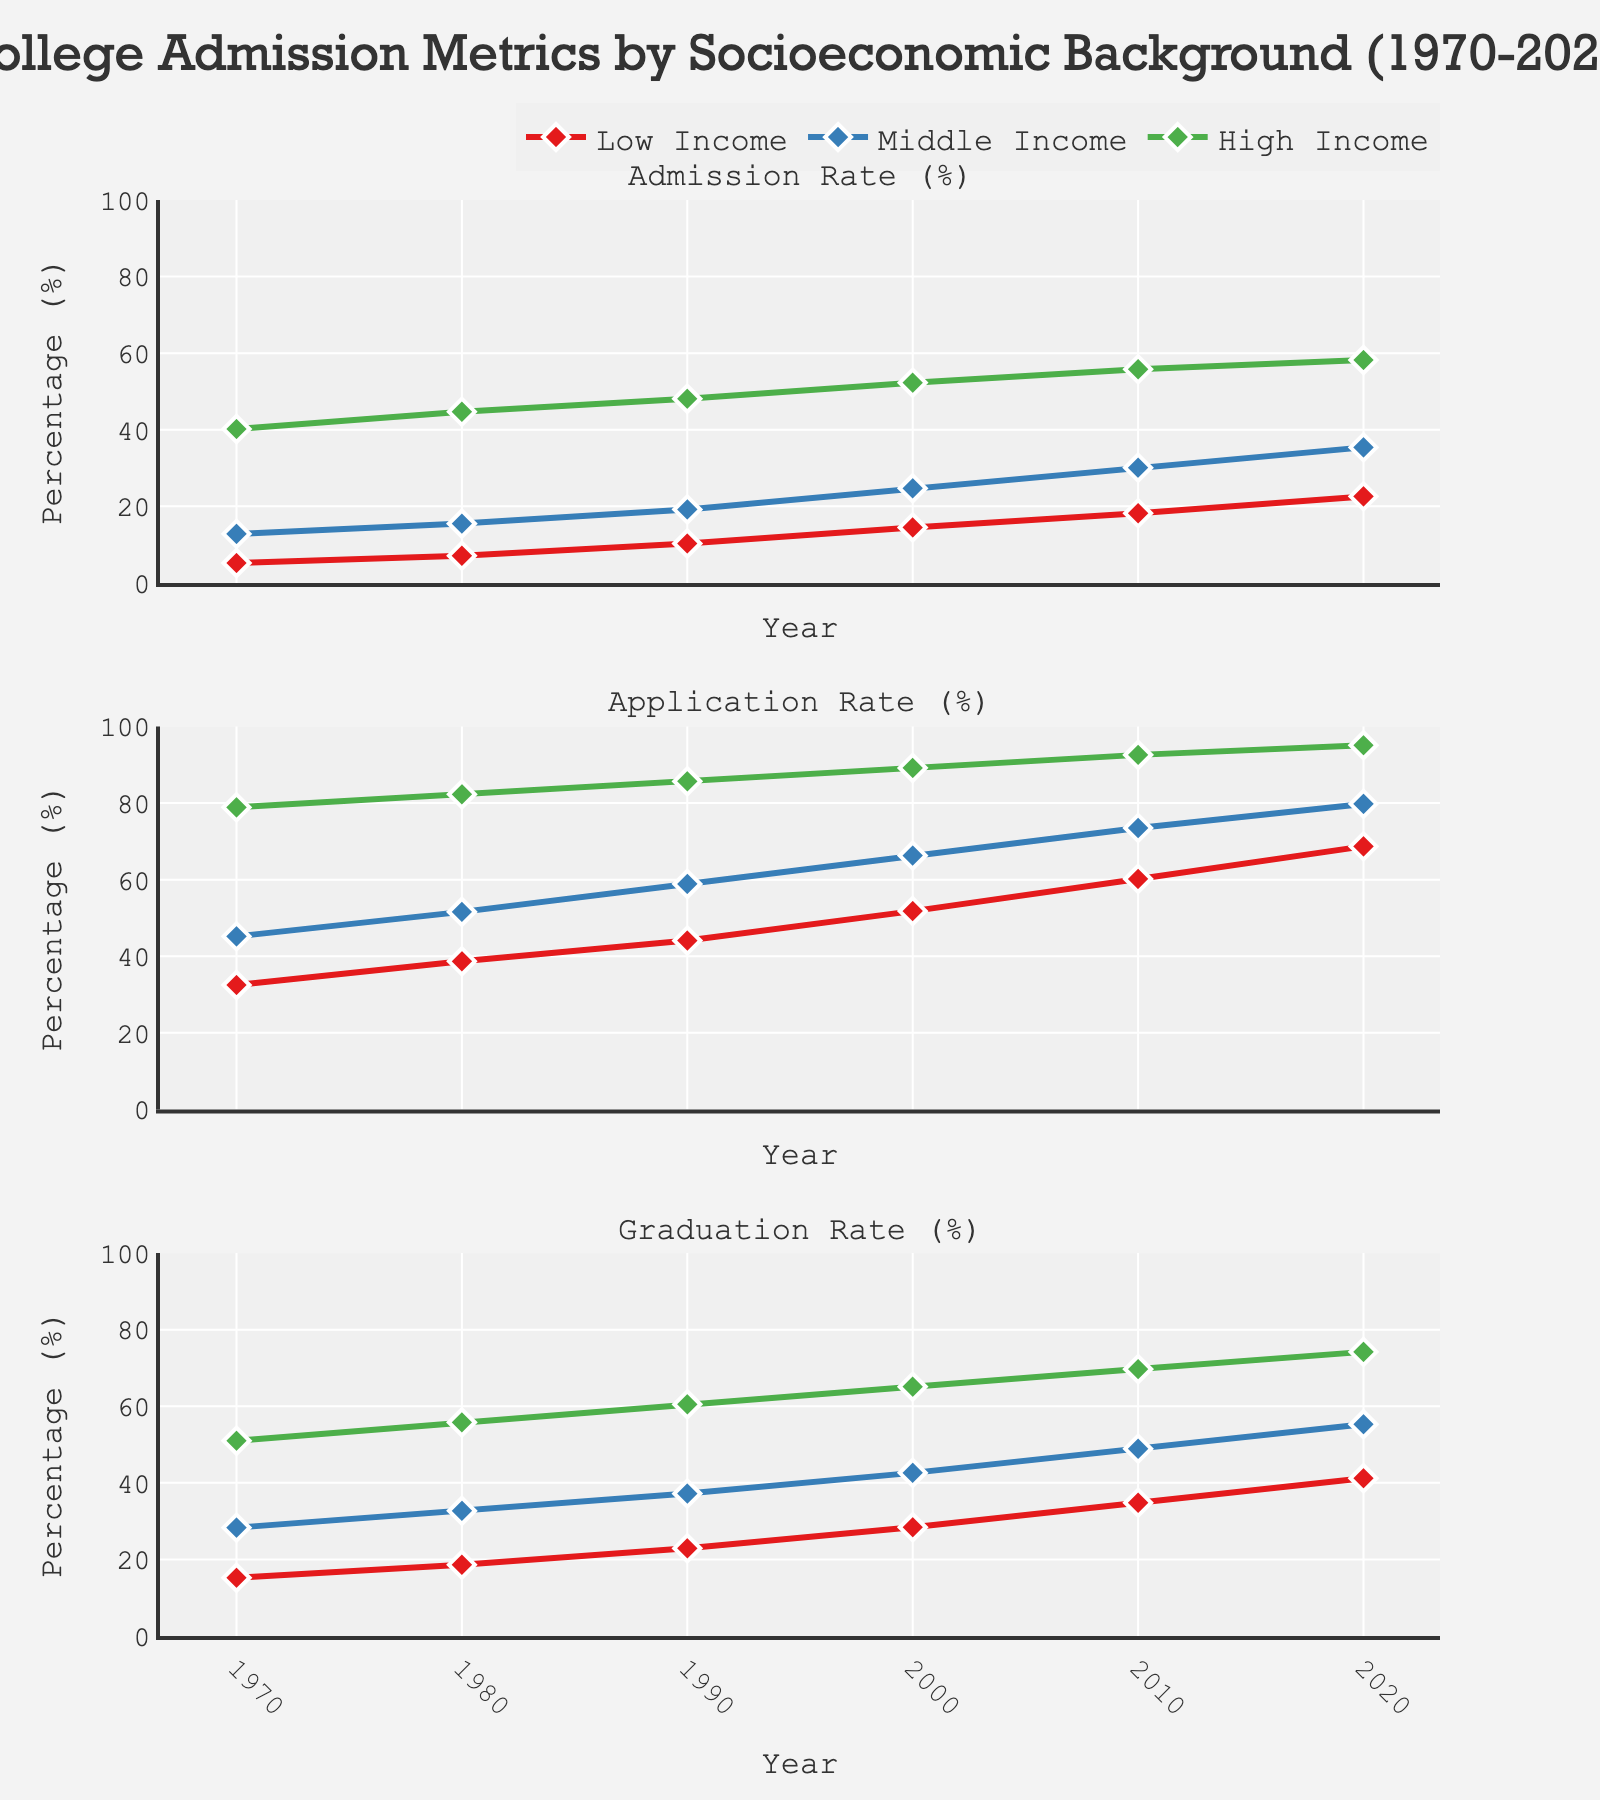What is the title of the figure? The title of the figure is positioned at the top center of the figure detailing its subject.
Answer: College Admission Metrics by Socioeconomic Background (1970-2020) How many subplots are present in the figure? The figure is divided into multiple sections, each representing a different metric.
Answer: 3 Which socioeconomic group had the highest admission rates in 2020? By examining the lines for the year 2020 in the admission rate subplot, one can identify the highest value.
Answer: High Income What was the percentage increase in the graduation rate for the Low Income group from 1970 to 2020? To calculate this percentage increase: subtract the 1970 value from the 2020 value, divide by the 1970 value, and multiply by 100. ((41.2 - 15.2) / 15.2) * 100 = 171.05
Answer: 171.05% Did the Middle Income group's application rates ever surpass the High Income group's rates in any year? Compare the application rates of the Middle Income and High Income groups year by year in the application rate subplot.
Answer: No What is the trend of admission rates for the Low Income group across all years? Observe the line for the Low Income group in the admission rate subplot to understand the direction of change over time.
Answer: Increasing Which year saw the largest increase in graduation rates for the High Income group? By finding the difference between consecutive years in the graduation rate subplot for the High Income group, identify the highest increase. From 1970 to 1980: (55.8 - 51.0) = 4.8, from 1980 to 1990: (60.5 - 55.8) = 4.7, from 1990 to 2000: (65.1 - 60.5) = 4.6, from 2000 to 2010: (69.7 - 65.1) = 4.6, from 2010 to 2020: (74.2 - 69.7) = 4.5. Hence, 1970 to 1980 had the largest increase of 4.8
Answer: 1970 to 1980 For the year 2000, what is the difference between the highest and lowest application rates among the three socioeconomic groups? Identify the highest and lowest application rates for the year 2000 from the application rate subplot, and compute the difference. Maximum (High Income) = 89.2, Minimum (Low Income) = 51.8. Difference: 89.2 - 51.8 = 37.4
Answer: 37.4 Did any socioeconomic group have a consistent growth in admission rates in all decades shown? Review the admission rate of each group over the decades to confirm if there is a consistent upward trend. All groups show consistent growth.
Answer: Yes 